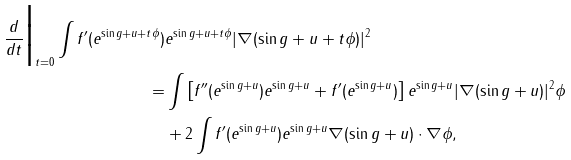Convert formula to latex. <formula><loc_0><loc_0><loc_500><loc_500>\frac { d } { d t } \Big | _ { t = 0 } \int f ^ { \prime } ( e ^ { \sin g + u + t \phi } ) & e ^ { \sin g + u + t \phi } | \nabla ( \sin g + u + t \phi ) | ^ { 2 } \\ = & \int \left [ f ^ { \prime \prime } ( e ^ { \sin g + u } ) e ^ { \sin g + u } + f ^ { \prime } ( e ^ { \sin g + u } ) \right ] e ^ { \sin g + u } | \nabla ( \sin g + u ) | ^ { 2 } \phi \\ & + 2 \int f ^ { \prime } ( e ^ { \sin g + u } ) e ^ { \sin g + u } \nabla ( \sin g + u ) \cdot \nabla \phi ,</formula> 